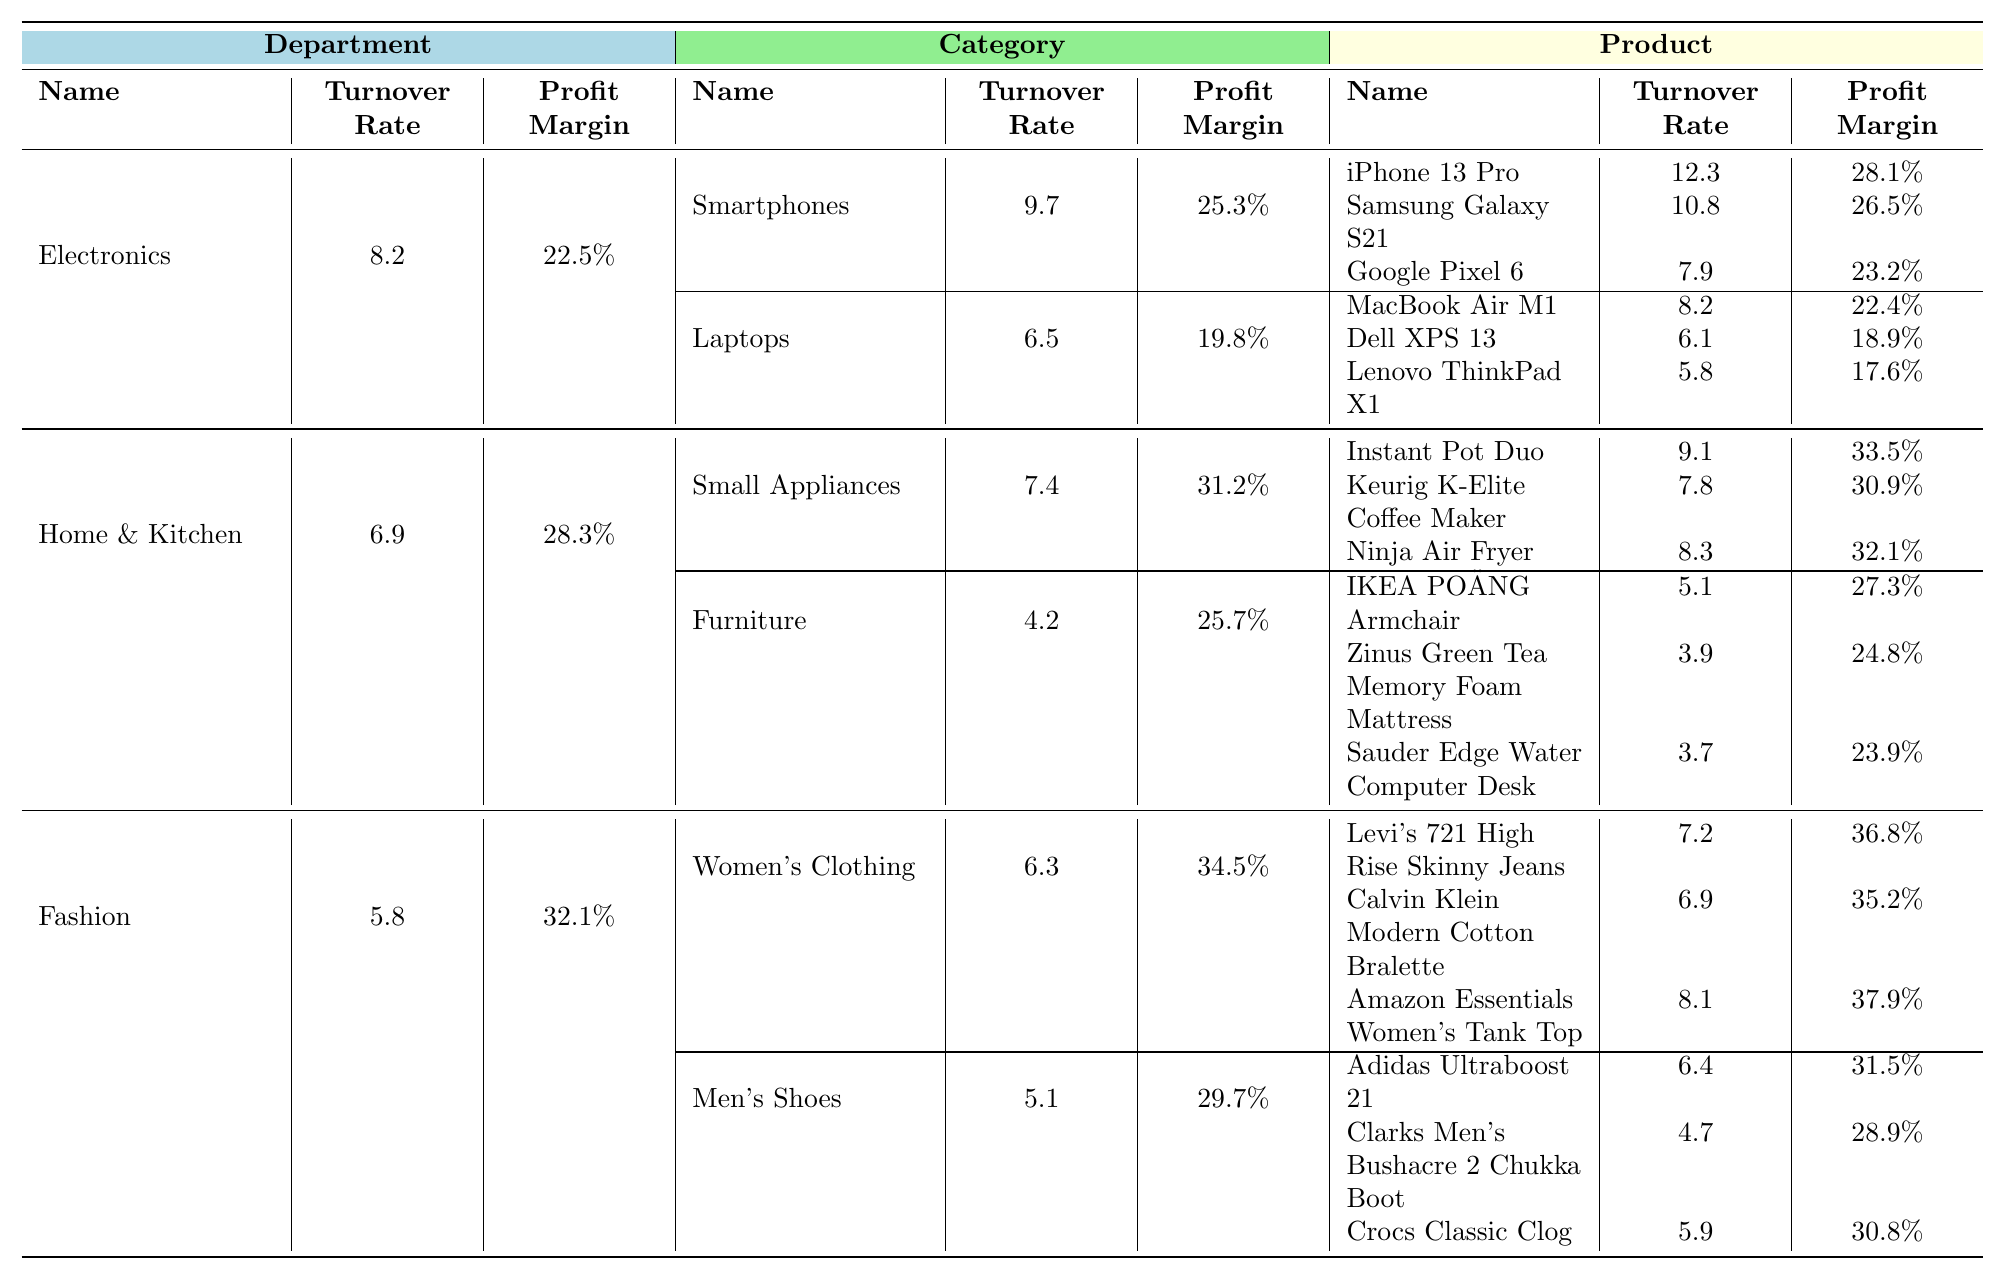What is the turnover rate for the Electronics department? The turnover rate for the Electronics department is explicitly indicated in the table under the corresponding section, which shows a value of 8.2.
Answer: 8.2 Which product in the Fashion department has the highest profit margin? By examining the profit margins of each product listed under the Fashion department, the Amazon Essentials Women's Tank Top has the highest profit margin at 37.9%.
Answer: Amazon Essentials Women's Tank Top What is the average turnover rate for the Small Appliances category? The turnover rates for the products in the Small Appliances category (Instant Pot Duo: 9.1, Keurig K-Elite Coffee Maker: 7.8, Ninja Air Fryer: 8.3) sum up to 9.1 + 7.8 + 8.3 = 25.2, and dividing by 3 (the number of products) gives an average of 25.2/3 = 8.4.
Answer: 8.4 Is the profit margin of the Lenovo ThinkPad X1 greater than 20%? The profit margin for the Lenovo ThinkPad X1 is 17.6%, which is less than 20%.
Answer: No Which department has a higher average profit margin, Electronics or Home & Kitchen? The average profit margin for the Electronics department is (22.5% + 25.3% + 19.8%) / 2 = 22.5%. For the Home & Kitchen department, the average is (28.3% + 31.2% + 25.7%) / 2 = 28.4%. Since 28.4% > 22.5%, Home & Kitchen has a higher average profit margin.
Answer: Home & Kitchen What is the total profit margin for all products in the Women's Clothing category? The profit margins in the Women's Clothing category are Levi's 721 High Rise Skinny Jeans (36.8%), Calvin Klein Modern Cotton Bralette (35.2%), and Amazon Essentials Women's Tank Top (37.9%). Their total is 36.8 + 35.2 + 37.9 = 109.9%.
Answer: 109.9% Who has a better turnover rate between the Dell XPS 13 and the IKEA POÄNG Armchair? The turnover rate for the Dell XPS 13 is 6.1 and for the IKEA POÄNG Armchair is 5.1. Since 6.1 > 5.1, the Dell XPS 13 has a better turnover rate.
Answer: Dell XPS 13 What is the profit margin difference between the Instant Pot Duo and the Keurig K-Elite Coffee Maker? The profit margin for the Instant Pot Duo is 33.5% and for the Keurig K-Elite Coffee Maker it is 30.9%. The difference is 33.5% - 30.9% = 2.6%.
Answer: 2.6% Are all categories in the Fashion department profitable with margins exceeding 25%? The profit margins for Women's Clothing (34.5% average) and Men's Shoes (29.7% average) both exceed 25%, confirming profitability in both categories.
Answer: Yes Which electronics product has the lowest turnover rate? Among the listed electronics products, the Google Pixel 6 has the lowest turnover rate at 7.9%.
Answer: Google Pixel 6 